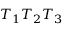Convert formula to latex. <formula><loc_0><loc_0><loc_500><loc_500>T _ { 1 } T _ { 2 } T _ { 3 }</formula> 